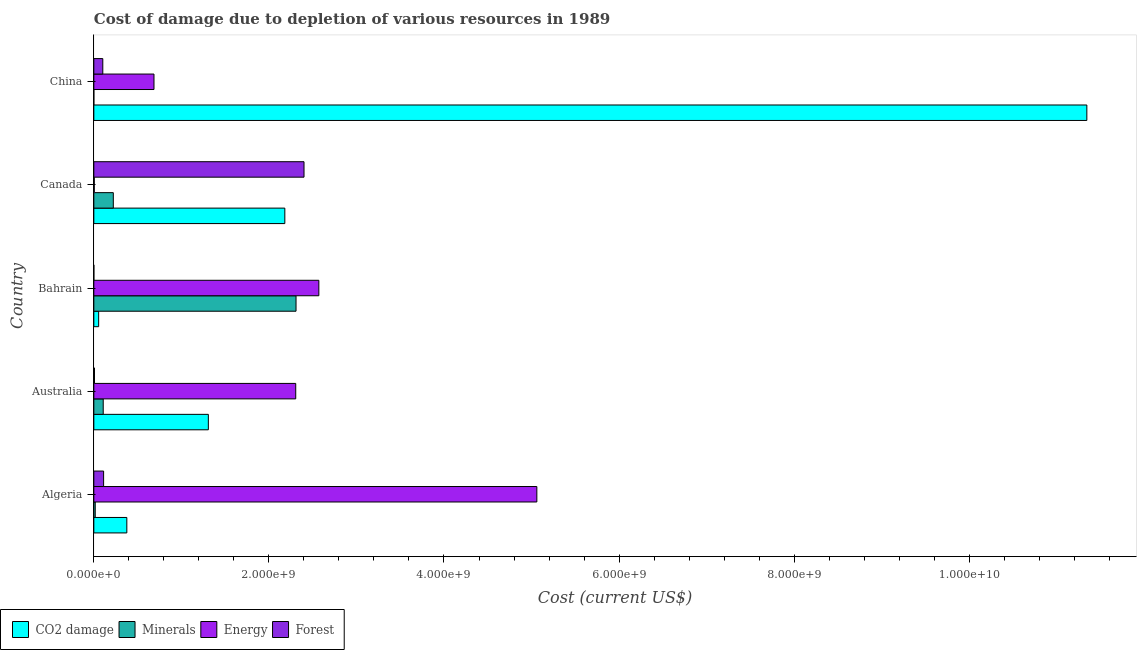Are the number of bars on each tick of the Y-axis equal?
Give a very brief answer. Yes. How many bars are there on the 4th tick from the top?
Your answer should be compact. 4. How many bars are there on the 4th tick from the bottom?
Offer a very short reply. 4. What is the label of the 1st group of bars from the top?
Provide a succinct answer. China. In how many cases, is the number of bars for a given country not equal to the number of legend labels?
Your answer should be compact. 0. What is the cost of damage due to depletion of energy in Bahrain?
Offer a very short reply. 2.57e+09. Across all countries, what is the maximum cost of damage due to depletion of energy?
Ensure brevity in your answer.  5.06e+09. Across all countries, what is the minimum cost of damage due to depletion of minerals?
Your response must be concise. 8972.38. In which country was the cost of damage due to depletion of minerals maximum?
Give a very brief answer. Bahrain. In which country was the cost of damage due to depletion of forests minimum?
Give a very brief answer. Bahrain. What is the total cost of damage due to depletion of coal in the graph?
Ensure brevity in your answer.  1.53e+1. What is the difference between the cost of damage due to depletion of coal in Algeria and that in China?
Your response must be concise. -1.10e+1. What is the difference between the cost of damage due to depletion of energy in Canada and the cost of damage due to depletion of coal in Bahrain?
Keep it short and to the point. -5.01e+07. What is the average cost of damage due to depletion of energy per country?
Provide a short and direct response. 2.13e+09. What is the difference between the cost of damage due to depletion of minerals and cost of damage due to depletion of energy in Bahrain?
Offer a very short reply. -2.61e+08. What is the ratio of the cost of damage due to depletion of energy in Algeria to that in Canada?
Ensure brevity in your answer.  979.07. Is the cost of damage due to depletion of forests in Australia less than that in China?
Provide a short and direct response. Yes. Is the difference between the cost of damage due to depletion of coal in Australia and Bahrain greater than the difference between the cost of damage due to depletion of minerals in Australia and Bahrain?
Offer a very short reply. Yes. What is the difference between the highest and the second highest cost of damage due to depletion of minerals?
Your answer should be very brief. 2.09e+09. What is the difference between the highest and the lowest cost of damage due to depletion of energy?
Provide a succinct answer. 5.06e+09. In how many countries, is the cost of damage due to depletion of coal greater than the average cost of damage due to depletion of coal taken over all countries?
Make the answer very short. 1. Is it the case that in every country, the sum of the cost of damage due to depletion of coal and cost of damage due to depletion of forests is greater than the sum of cost of damage due to depletion of minerals and cost of damage due to depletion of energy?
Your answer should be very brief. No. What does the 4th bar from the top in China represents?
Keep it short and to the point. CO2 damage. What does the 3rd bar from the bottom in Algeria represents?
Give a very brief answer. Energy. Is it the case that in every country, the sum of the cost of damage due to depletion of coal and cost of damage due to depletion of minerals is greater than the cost of damage due to depletion of energy?
Make the answer very short. No. How many bars are there?
Provide a short and direct response. 20. Are all the bars in the graph horizontal?
Make the answer very short. Yes. How many countries are there in the graph?
Provide a short and direct response. 5. Does the graph contain any zero values?
Your answer should be compact. No. Does the graph contain grids?
Your response must be concise. No. Where does the legend appear in the graph?
Give a very brief answer. Bottom left. What is the title of the graph?
Ensure brevity in your answer.  Cost of damage due to depletion of various resources in 1989 . What is the label or title of the X-axis?
Offer a very short reply. Cost (current US$). What is the Cost (current US$) of CO2 damage in Algeria?
Your response must be concise. 3.77e+08. What is the Cost (current US$) in Minerals in Algeria?
Ensure brevity in your answer.  1.62e+07. What is the Cost (current US$) in Energy in Algeria?
Offer a very short reply. 5.06e+09. What is the Cost (current US$) in Forest in Algeria?
Give a very brief answer. 1.12e+08. What is the Cost (current US$) in CO2 damage in Australia?
Ensure brevity in your answer.  1.31e+09. What is the Cost (current US$) of Minerals in Australia?
Offer a terse response. 1.07e+08. What is the Cost (current US$) of Energy in Australia?
Offer a very short reply. 2.31e+09. What is the Cost (current US$) of Forest in Australia?
Provide a short and direct response. 7.81e+06. What is the Cost (current US$) of CO2 damage in Bahrain?
Keep it short and to the point. 5.53e+07. What is the Cost (current US$) in Minerals in Bahrain?
Provide a succinct answer. 2.31e+09. What is the Cost (current US$) in Energy in Bahrain?
Offer a very short reply. 2.57e+09. What is the Cost (current US$) in Forest in Bahrain?
Offer a terse response. 1.86e+05. What is the Cost (current US$) in CO2 damage in Canada?
Offer a terse response. 2.18e+09. What is the Cost (current US$) of Minerals in Canada?
Provide a short and direct response. 2.23e+08. What is the Cost (current US$) in Energy in Canada?
Provide a succinct answer. 5.17e+06. What is the Cost (current US$) in Forest in Canada?
Ensure brevity in your answer.  2.40e+09. What is the Cost (current US$) in CO2 damage in China?
Your answer should be compact. 1.13e+1. What is the Cost (current US$) in Minerals in China?
Ensure brevity in your answer.  8972.38. What is the Cost (current US$) in Energy in China?
Offer a very short reply. 6.87e+08. What is the Cost (current US$) of Forest in China?
Ensure brevity in your answer.  1.03e+08. Across all countries, what is the maximum Cost (current US$) of CO2 damage?
Keep it short and to the point. 1.13e+1. Across all countries, what is the maximum Cost (current US$) in Minerals?
Ensure brevity in your answer.  2.31e+09. Across all countries, what is the maximum Cost (current US$) of Energy?
Your answer should be very brief. 5.06e+09. Across all countries, what is the maximum Cost (current US$) in Forest?
Keep it short and to the point. 2.40e+09. Across all countries, what is the minimum Cost (current US$) in CO2 damage?
Provide a short and direct response. 5.53e+07. Across all countries, what is the minimum Cost (current US$) in Minerals?
Your answer should be compact. 8972.38. Across all countries, what is the minimum Cost (current US$) in Energy?
Your response must be concise. 5.17e+06. Across all countries, what is the minimum Cost (current US$) in Forest?
Make the answer very short. 1.86e+05. What is the total Cost (current US$) of CO2 damage in the graph?
Keep it short and to the point. 1.53e+1. What is the total Cost (current US$) in Minerals in the graph?
Give a very brief answer. 2.66e+09. What is the total Cost (current US$) in Energy in the graph?
Your response must be concise. 1.06e+1. What is the total Cost (current US$) of Forest in the graph?
Give a very brief answer. 2.62e+09. What is the difference between the Cost (current US$) in CO2 damage in Algeria and that in Australia?
Give a very brief answer. -9.31e+08. What is the difference between the Cost (current US$) of Minerals in Algeria and that in Australia?
Provide a short and direct response. -9.11e+07. What is the difference between the Cost (current US$) of Energy in Algeria and that in Australia?
Keep it short and to the point. 2.75e+09. What is the difference between the Cost (current US$) of Forest in Algeria and that in Australia?
Make the answer very short. 1.04e+08. What is the difference between the Cost (current US$) in CO2 damage in Algeria and that in Bahrain?
Keep it short and to the point. 3.22e+08. What is the difference between the Cost (current US$) of Minerals in Algeria and that in Bahrain?
Your response must be concise. -2.29e+09. What is the difference between the Cost (current US$) of Energy in Algeria and that in Bahrain?
Offer a very short reply. 2.49e+09. What is the difference between the Cost (current US$) of Forest in Algeria and that in Bahrain?
Provide a short and direct response. 1.12e+08. What is the difference between the Cost (current US$) of CO2 damage in Algeria and that in Canada?
Offer a terse response. -1.80e+09. What is the difference between the Cost (current US$) in Minerals in Algeria and that in Canada?
Provide a succinct answer. -2.06e+08. What is the difference between the Cost (current US$) of Energy in Algeria and that in Canada?
Keep it short and to the point. 5.06e+09. What is the difference between the Cost (current US$) in Forest in Algeria and that in Canada?
Give a very brief answer. -2.29e+09. What is the difference between the Cost (current US$) in CO2 damage in Algeria and that in China?
Ensure brevity in your answer.  -1.10e+1. What is the difference between the Cost (current US$) in Minerals in Algeria and that in China?
Your answer should be very brief. 1.62e+07. What is the difference between the Cost (current US$) in Energy in Algeria and that in China?
Your answer should be compact. 4.37e+09. What is the difference between the Cost (current US$) of Forest in Algeria and that in China?
Make the answer very short. 9.30e+06. What is the difference between the Cost (current US$) in CO2 damage in Australia and that in Bahrain?
Ensure brevity in your answer.  1.25e+09. What is the difference between the Cost (current US$) of Minerals in Australia and that in Bahrain?
Make the answer very short. -2.20e+09. What is the difference between the Cost (current US$) of Energy in Australia and that in Bahrain?
Provide a succinct answer. -2.64e+08. What is the difference between the Cost (current US$) in Forest in Australia and that in Bahrain?
Your answer should be compact. 7.63e+06. What is the difference between the Cost (current US$) of CO2 damage in Australia and that in Canada?
Your response must be concise. -8.74e+08. What is the difference between the Cost (current US$) of Minerals in Australia and that in Canada?
Your answer should be compact. -1.15e+08. What is the difference between the Cost (current US$) of Energy in Australia and that in Canada?
Give a very brief answer. 2.30e+09. What is the difference between the Cost (current US$) of Forest in Australia and that in Canada?
Your response must be concise. -2.39e+09. What is the difference between the Cost (current US$) in CO2 damage in Australia and that in China?
Make the answer very short. -1.00e+1. What is the difference between the Cost (current US$) of Minerals in Australia and that in China?
Your response must be concise. 1.07e+08. What is the difference between the Cost (current US$) of Energy in Australia and that in China?
Keep it short and to the point. 1.62e+09. What is the difference between the Cost (current US$) of Forest in Australia and that in China?
Keep it short and to the point. -9.47e+07. What is the difference between the Cost (current US$) in CO2 damage in Bahrain and that in Canada?
Ensure brevity in your answer.  -2.13e+09. What is the difference between the Cost (current US$) of Minerals in Bahrain and that in Canada?
Ensure brevity in your answer.  2.09e+09. What is the difference between the Cost (current US$) in Energy in Bahrain and that in Canada?
Your answer should be very brief. 2.57e+09. What is the difference between the Cost (current US$) of Forest in Bahrain and that in Canada?
Provide a succinct answer. -2.40e+09. What is the difference between the Cost (current US$) in CO2 damage in Bahrain and that in China?
Ensure brevity in your answer.  -1.13e+1. What is the difference between the Cost (current US$) of Minerals in Bahrain and that in China?
Offer a very short reply. 2.31e+09. What is the difference between the Cost (current US$) in Energy in Bahrain and that in China?
Offer a terse response. 1.88e+09. What is the difference between the Cost (current US$) of Forest in Bahrain and that in China?
Give a very brief answer. -1.02e+08. What is the difference between the Cost (current US$) of CO2 damage in Canada and that in China?
Your response must be concise. -9.16e+09. What is the difference between the Cost (current US$) in Minerals in Canada and that in China?
Your response must be concise. 2.23e+08. What is the difference between the Cost (current US$) in Energy in Canada and that in China?
Ensure brevity in your answer.  -6.82e+08. What is the difference between the Cost (current US$) in Forest in Canada and that in China?
Provide a short and direct response. 2.30e+09. What is the difference between the Cost (current US$) in CO2 damage in Algeria and the Cost (current US$) in Minerals in Australia?
Your answer should be very brief. 2.70e+08. What is the difference between the Cost (current US$) in CO2 damage in Algeria and the Cost (current US$) in Energy in Australia?
Keep it short and to the point. -1.93e+09. What is the difference between the Cost (current US$) in CO2 damage in Algeria and the Cost (current US$) in Forest in Australia?
Ensure brevity in your answer.  3.69e+08. What is the difference between the Cost (current US$) in Minerals in Algeria and the Cost (current US$) in Energy in Australia?
Ensure brevity in your answer.  -2.29e+09. What is the difference between the Cost (current US$) in Minerals in Algeria and the Cost (current US$) in Forest in Australia?
Make the answer very short. 8.40e+06. What is the difference between the Cost (current US$) of Energy in Algeria and the Cost (current US$) of Forest in Australia?
Ensure brevity in your answer.  5.05e+09. What is the difference between the Cost (current US$) in CO2 damage in Algeria and the Cost (current US$) in Minerals in Bahrain?
Provide a short and direct response. -1.93e+09. What is the difference between the Cost (current US$) in CO2 damage in Algeria and the Cost (current US$) in Energy in Bahrain?
Give a very brief answer. -2.19e+09. What is the difference between the Cost (current US$) in CO2 damage in Algeria and the Cost (current US$) in Forest in Bahrain?
Offer a very short reply. 3.77e+08. What is the difference between the Cost (current US$) of Minerals in Algeria and the Cost (current US$) of Energy in Bahrain?
Offer a terse response. -2.55e+09. What is the difference between the Cost (current US$) of Minerals in Algeria and the Cost (current US$) of Forest in Bahrain?
Offer a very short reply. 1.60e+07. What is the difference between the Cost (current US$) of Energy in Algeria and the Cost (current US$) of Forest in Bahrain?
Your answer should be compact. 5.06e+09. What is the difference between the Cost (current US$) of CO2 damage in Algeria and the Cost (current US$) of Minerals in Canada?
Offer a very short reply. 1.54e+08. What is the difference between the Cost (current US$) in CO2 damage in Algeria and the Cost (current US$) in Energy in Canada?
Keep it short and to the point. 3.72e+08. What is the difference between the Cost (current US$) in CO2 damage in Algeria and the Cost (current US$) in Forest in Canada?
Ensure brevity in your answer.  -2.02e+09. What is the difference between the Cost (current US$) of Minerals in Algeria and the Cost (current US$) of Energy in Canada?
Your answer should be compact. 1.10e+07. What is the difference between the Cost (current US$) of Minerals in Algeria and the Cost (current US$) of Forest in Canada?
Keep it short and to the point. -2.38e+09. What is the difference between the Cost (current US$) in Energy in Algeria and the Cost (current US$) in Forest in Canada?
Your response must be concise. 2.66e+09. What is the difference between the Cost (current US$) in CO2 damage in Algeria and the Cost (current US$) in Minerals in China?
Your answer should be very brief. 3.77e+08. What is the difference between the Cost (current US$) of CO2 damage in Algeria and the Cost (current US$) of Energy in China?
Ensure brevity in your answer.  -3.10e+08. What is the difference between the Cost (current US$) of CO2 damage in Algeria and the Cost (current US$) of Forest in China?
Your answer should be compact. 2.74e+08. What is the difference between the Cost (current US$) in Minerals in Algeria and the Cost (current US$) in Energy in China?
Your answer should be compact. -6.71e+08. What is the difference between the Cost (current US$) in Minerals in Algeria and the Cost (current US$) in Forest in China?
Provide a short and direct response. -8.63e+07. What is the difference between the Cost (current US$) in Energy in Algeria and the Cost (current US$) in Forest in China?
Make the answer very short. 4.96e+09. What is the difference between the Cost (current US$) in CO2 damage in Australia and the Cost (current US$) in Minerals in Bahrain?
Your response must be concise. -1.00e+09. What is the difference between the Cost (current US$) of CO2 damage in Australia and the Cost (current US$) of Energy in Bahrain?
Give a very brief answer. -1.26e+09. What is the difference between the Cost (current US$) of CO2 damage in Australia and the Cost (current US$) of Forest in Bahrain?
Your answer should be very brief. 1.31e+09. What is the difference between the Cost (current US$) in Minerals in Australia and the Cost (current US$) in Energy in Bahrain?
Offer a very short reply. -2.46e+09. What is the difference between the Cost (current US$) of Minerals in Australia and the Cost (current US$) of Forest in Bahrain?
Keep it short and to the point. 1.07e+08. What is the difference between the Cost (current US$) of Energy in Australia and the Cost (current US$) of Forest in Bahrain?
Provide a short and direct response. 2.31e+09. What is the difference between the Cost (current US$) of CO2 damage in Australia and the Cost (current US$) of Minerals in Canada?
Give a very brief answer. 1.09e+09. What is the difference between the Cost (current US$) of CO2 damage in Australia and the Cost (current US$) of Energy in Canada?
Your response must be concise. 1.30e+09. What is the difference between the Cost (current US$) in CO2 damage in Australia and the Cost (current US$) in Forest in Canada?
Provide a succinct answer. -1.09e+09. What is the difference between the Cost (current US$) in Minerals in Australia and the Cost (current US$) in Energy in Canada?
Provide a succinct answer. 1.02e+08. What is the difference between the Cost (current US$) of Minerals in Australia and the Cost (current US$) of Forest in Canada?
Offer a very short reply. -2.29e+09. What is the difference between the Cost (current US$) in Energy in Australia and the Cost (current US$) in Forest in Canada?
Provide a succinct answer. -9.47e+07. What is the difference between the Cost (current US$) of CO2 damage in Australia and the Cost (current US$) of Minerals in China?
Your answer should be compact. 1.31e+09. What is the difference between the Cost (current US$) of CO2 damage in Australia and the Cost (current US$) of Energy in China?
Offer a terse response. 6.21e+08. What is the difference between the Cost (current US$) in CO2 damage in Australia and the Cost (current US$) in Forest in China?
Ensure brevity in your answer.  1.21e+09. What is the difference between the Cost (current US$) in Minerals in Australia and the Cost (current US$) in Energy in China?
Ensure brevity in your answer.  -5.80e+08. What is the difference between the Cost (current US$) of Minerals in Australia and the Cost (current US$) of Forest in China?
Your answer should be compact. 4.79e+06. What is the difference between the Cost (current US$) of Energy in Australia and the Cost (current US$) of Forest in China?
Your answer should be very brief. 2.20e+09. What is the difference between the Cost (current US$) of CO2 damage in Bahrain and the Cost (current US$) of Minerals in Canada?
Your answer should be very brief. -1.67e+08. What is the difference between the Cost (current US$) of CO2 damage in Bahrain and the Cost (current US$) of Energy in Canada?
Give a very brief answer. 5.01e+07. What is the difference between the Cost (current US$) of CO2 damage in Bahrain and the Cost (current US$) of Forest in Canada?
Offer a very short reply. -2.35e+09. What is the difference between the Cost (current US$) in Minerals in Bahrain and the Cost (current US$) in Energy in Canada?
Provide a succinct answer. 2.30e+09. What is the difference between the Cost (current US$) in Minerals in Bahrain and the Cost (current US$) in Forest in Canada?
Give a very brief answer. -9.13e+07. What is the difference between the Cost (current US$) of Energy in Bahrain and the Cost (current US$) of Forest in Canada?
Provide a succinct answer. 1.69e+08. What is the difference between the Cost (current US$) in CO2 damage in Bahrain and the Cost (current US$) in Minerals in China?
Make the answer very short. 5.53e+07. What is the difference between the Cost (current US$) in CO2 damage in Bahrain and the Cost (current US$) in Energy in China?
Give a very brief answer. -6.32e+08. What is the difference between the Cost (current US$) in CO2 damage in Bahrain and the Cost (current US$) in Forest in China?
Offer a very short reply. -4.73e+07. What is the difference between the Cost (current US$) in Minerals in Bahrain and the Cost (current US$) in Energy in China?
Keep it short and to the point. 1.62e+09. What is the difference between the Cost (current US$) in Minerals in Bahrain and the Cost (current US$) in Forest in China?
Provide a succinct answer. 2.21e+09. What is the difference between the Cost (current US$) in Energy in Bahrain and the Cost (current US$) in Forest in China?
Ensure brevity in your answer.  2.47e+09. What is the difference between the Cost (current US$) of CO2 damage in Canada and the Cost (current US$) of Minerals in China?
Provide a succinct answer. 2.18e+09. What is the difference between the Cost (current US$) of CO2 damage in Canada and the Cost (current US$) of Energy in China?
Provide a short and direct response. 1.49e+09. What is the difference between the Cost (current US$) of CO2 damage in Canada and the Cost (current US$) of Forest in China?
Make the answer very short. 2.08e+09. What is the difference between the Cost (current US$) in Minerals in Canada and the Cost (current US$) in Energy in China?
Your answer should be compact. -4.65e+08. What is the difference between the Cost (current US$) of Minerals in Canada and the Cost (current US$) of Forest in China?
Provide a short and direct response. 1.20e+08. What is the difference between the Cost (current US$) in Energy in Canada and the Cost (current US$) in Forest in China?
Keep it short and to the point. -9.74e+07. What is the average Cost (current US$) in CO2 damage per country?
Your answer should be very brief. 3.05e+09. What is the average Cost (current US$) in Minerals per country?
Ensure brevity in your answer.  5.31e+08. What is the average Cost (current US$) in Energy per country?
Your answer should be very brief. 2.13e+09. What is the average Cost (current US$) of Forest per country?
Keep it short and to the point. 5.25e+08. What is the difference between the Cost (current US$) in CO2 damage and Cost (current US$) in Minerals in Algeria?
Keep it short and to the point. 3.61e+08. What is the difference between the Cost (current US$) in CO2 damage and Cost (current US$) in Energy in Algeria?
Your response must be concise. -4.68e+09. What is the difference between the Cost (current US$) in CO2 damage and Cost (current US$) in Forest in Algeria?
Provide a succinct answer. 2.65e+08. What is the difference between the Cost (current US$) of Minerals and Cost (current US$) of Energy in Algeria?
Provide a succinct answer. -5.04e+09. What is the difference between the Cost (current US$) of Minerals and Cost (current US$) of Forest in Algeria?
Your answer should be very brief. -9.56e+07. What is the difference between the Cost (current US$) of Energy and Cost (current US$) of Forest in Algeria?
Offer a very short reply. 4.95e+09. What is the difference between the Cost (current US$) of CO2 damage and Cost (current US$) of Minerals in Australia?
Your response must be concise. 1.20e+09. What is the difference between the Cost (current US$) in CO2 damage and Cost (current US$) in Energy in Australia?
Your response must be concise. -9.98e+08. What is the difference between the Cost (current US$) in CO2 damage and Cost (current US$) in Forest in Australia?
Ensure brevity in your answer.  1.30e+09. What is the difference between the Cost (current US$) of Minerals and Cost (current US$) of Energy in Australia?
Your answer should be compact. -2.20e+09. What is the difference between the Cost (current US$) in Minerals and Cost (current US$) in Forest in Australia?
Your answer should be very brief. 9.95e+07. What is the difference between the Cost (current US$) in Energy and Cost (current US$) in Forest in Australia?
Your answer should be compact. 2.30e+09. What is the difference between the Cost (current US$) in CO2 damage and Cost (current US$) in Minerals in Bahrain?
Your answer should be very brief. -2.25e+09. What is the difference between the Cost (current US$) of CO2 damage and Cost (current US$) of Energy in Bahrain?
Your answer should be very brief. -2.52e+09. What is the difference between the Cost (current US$) in CO2 damage and Cost (current US$) in Forest in Bahrain?
Offer a terse response. 5.51e+07. What is the difference between the Cost (current US$) in Minerals and Cost (current US$) in Energy in Bahrain?
Your answer should be compact. -2.61e+08. What is the difference between the Cost (current US$) of Minerals and Cost (current US$) of Forest in Bahrain?
Keep it short and to the point. 2.31e+09. What is the difference between the Cost (current US$) of Energy and Cost (current US$) of Forest in Bahrain?
Make the answer very short. 2.57e+09. What is the difference between the Cost (current US$) in CO2 damage and Cost (current US$) in Minerals in Canada?
Provide a succinct answer. 1.96e+09. What is the difference between the Cost (current US$) in CO2 damage and Cost (current US$) in Energy in Canada?
Your response must be concise. 2.18e+09. What is the difference between the Cost (current US$) of CO2 damage and Cost (current US$) of Forest in Canada?
Your answer should be compact. -2.19e+08. What is the difference between the Cost (current US$) of Minerals and Cost (current US$) of Energy in Canada?
Offer a very short reply. 2.17e+08. What is the difference between the Cost (current US$) in Minerals and Cost (current US$) in Forest in Canada?
Ensure brevity in your answer.  -2.18e+09. What is the difference between the Cost (current US$) in Energy and Cost (current US$) in Forest in Canada?
Give a very brief answer. -2.40e+09. What is the difference between the Cost (current US$) of CO2 damage and Cost (current US$) of Minerals in China?
Your response must be concise. 1.13e+1. What is the difference between the Cost (current US$) of CO2 damage and Cost (current US$) of Energy in China?
Make the answer very short. 1.07e+1. What is the difference between the Cost (current US$) of CO2 damage and Cost (current US$) of Forest in China?
Ensure brevity in your answer.  1.12e+1. What is the difference between the Cost (current US$) of Minerals and Cost (current US$) of Energy in China?
Your answer should be compact. -6.87e+08. What is the difference between the Cost (current US$) in Minerals and Cost (current US$) in Forest in China?
Your answer should be compact. -1.03e+08. What is the difference between the Cost (current US$) in Energy and Cost (current US$) in Forest in China?
Make the answer very short. 5.85e+08. What is the ratio of the Cost (current US$) of CO2 damage in Algeria to that in Australia?
Make the answer very short. 0.29. What is the ratio of the Cost (current US$) of Minerals in Algeria to that in Australia?
Your response must be concise. 0.15. What is the ratio of the Cost (current US$) in Energy in Algeria to that in Australia?
Give a very brief answer. 2.19. What is the ratio of the Cost (current US$) in Forest in Algeria to that in Australia?
Offer a terse response. 14.32. What is the ratio of the Cost (current US$) of CO2 damage in Algeria to that in Bahrain?
Provide a short and direct response. 6.82. What is the ratio of the Cost (current US$) in Minerals in Algeria to that in Bahrain?
Make the answer very short. 0.01. What is the ratio of the Cost (current US$) in Energy in Algeria to that in Bahrain?
Keep it short and to the point. 1.97. What is the ratio of the Cost (current US$) of Forest in Algeria to that in Bahrain?
Provide a succinct answer. 600.28. What is the ratio of the Cost (current US$) of CO2 damage in Algeria to that in Canada?
Your answer should be very brief. 0.17. What is the ratio of the Cost (current US$) of Minerals in Algeria to that in Canada?
Keep it short and to the point. 0.07. What is the ratio of the Cost (current US$) of Energy in Algeria to that in Canada?
Provide a succinct answer. 979.07. What is the ratio of the Cost (current US$) in Forest in Algeria to that in Canada?
Offer a very short reply. 0.05. What is the ratio of the Cost (current US$) of CO2 damage in Algeria to that in China?
Keep it short and to the point. 0.03. What is the ratio of the Cost (current US$) in Minerals in Algeria to that in China?
Give a very brief answer. 1807.37. What is the ratio of the Cost (current US$) of Energy in Algeria to that in China?
Your answer should be very brief. 7.36. What is the ratio of the Cost (current US$) in Forest in Algeria to that in China?
Your response must be concise. 1.09. What is the ratio of the Cost (current US$) of CO2 damage in Australia to that in Bahrain?
Your answer should be compact. 23.66. What is the ratio of the Cost (current US$) in Minerals in Australia to that in Bahrain?
Offer a terse response. 0.05. What is the ratio of the Cost (current US$) in Energy in Australia to that in Bahrain?
Your response must be concise. 0.9. What is the ratio of the Cost (current US$) of Forest in Australia to that in Bahrain?
Provide a succinct answer. 41.93. What is the ratio of the Cost (current US$) in CO2 damage in Australia to that in Canada?
Your answer should be very brief. 0.6. What is the ratio of the Cost (current US$) in Minerals in Australia to that in Canada?
Ensure brevity in your answer.  0.48. What is the ratio of the Cost (current US$) of Energy in Australia to that in Canada?
Your answer should be compact. 446.22. What is the ratio of the Cost (current US$) of Forest in Australia to that in Canada?
Your answer should be very brief. 0. What is the ratio of the Cost (current US$) of CO2 damage in Australia to that in China?
Your answer should be very brief. 0.12. What is the ratio of the Cost (current US$) of Minerals in Australia to that in China?
Offer a terse response. 1.20e+04. What is the ratio of the Cost (current US$) in Energy in Australia to that in China?
Your answer should be compact. 3.36. What is the ratio of the Cost (current US$) of Forest in Australia to that in China?
Offer a terse response. 0.08. What is the ratio of the Cost (current US$) of CO2 damage in Bahrain to that in Canada?
Your answer should be compact. 0.03. What is the ratio of the Cost (current US$) of Minerals in Bahrain to that in Canada?
Provide a short and direct response. 10.38. What is the ratio of the Cost (current US$) of Energy in Bahrain to that in Canada?
Make the answer very short. 497.29. What is the ratio of the Cost (current US$) of CO2 damage in Bahrain to that in China?
Your response must be concise. 0. What is the ratio of the Cost (current US$) in Minerals in Bahrain to that in China?
Offer a terse response. 2.57e+05. What is the ratio of the Cost (current US$) of Energy in Bahrain to that in China?
Provide a short and direct response. 3.74. What is the ratio of the Cost (current US$) of Forest in Bahrain to that in China?
Provide a succinct answer. 0. What is the ratio of the Cost (current US$) of CO2 damage in Canada to that in China?
Your response must be concise. 0.19. What is the ratio of the Cost (current US$) of Minerals in Canada to that in China?
Your answer should be very brief. 2.48e+04. What is the ratio of the Cost (current US$) of Energy in Canada to that in China?
Ensure brevity in your answer.  0.01. What is the ratio of the Cost (current US$) in Forest in Canada to that in China?
Give a very brief answer. 23.41. What is the difference between the highest and the second highest Cost (current US$) of CO2 damage?
Offer a very short reply. 9.16e+09. What is the difference between the highest and the second highest Cost (current US$) of Minerals?
Provide a succinct answer. 2.09e+09. What is the difference between the highest and the second highest Cost (current US$) in Energy?
Offer a very short reply. 2.49e+09. What is the difference between the highest and the second highest Cost (current US$) in Forest?
Give a very brief answer. 2.29e+09. What is the difference between the highest and the lowest Cost (current US$) in CO2 damage?
Offer a very short reply. 1.13e+1. What is the difference between the highest and the lowest Cost (current US$) in Minerals?
Give a very brief answer. 2.31e+09. What is the difference between the highest and the lowest Cost (current US$) in Energy?
Keep it short and to the point. 5.06e+09. What is the difference between the highest and the lowest Cost (current US$) in Forest?
Give a very brief answer. 2.40e+09. 